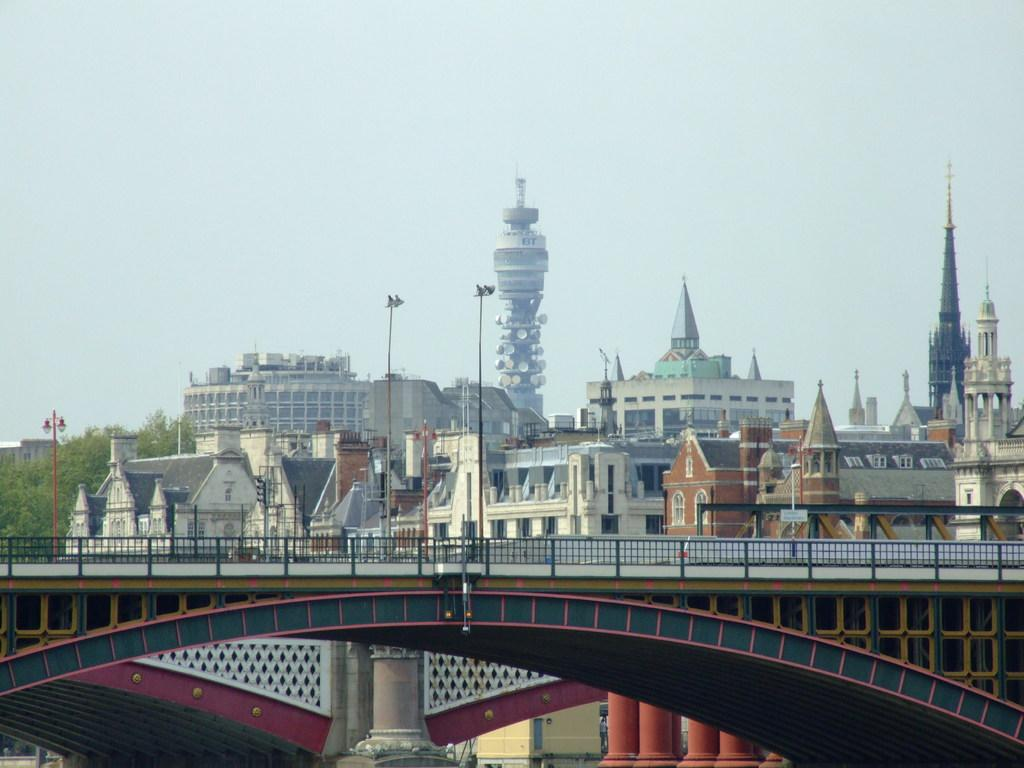What structure is the main subject of the image? There is a bridge in the image. What feature does the bridge have? The bridge has a railing. What can be seen behind the bridge? There are buildings behind the bridge. What else is present in the image besides the bridge? There are poles with lights and trees visible in the image. What is visible in the background of the image? The sky is visible in the background of the image. What type of dinner is being prepared by the mom in the image? There is no mom or dinner preparation present in the image; it features a bridge with a railing, buildings, poles with lights, trees, and a visible sky. What key is used to unlock the door in the image? There is no door or key present in the image; it features a bridge with a railing, buildings, poles with lights, trees, and a visible sky. 